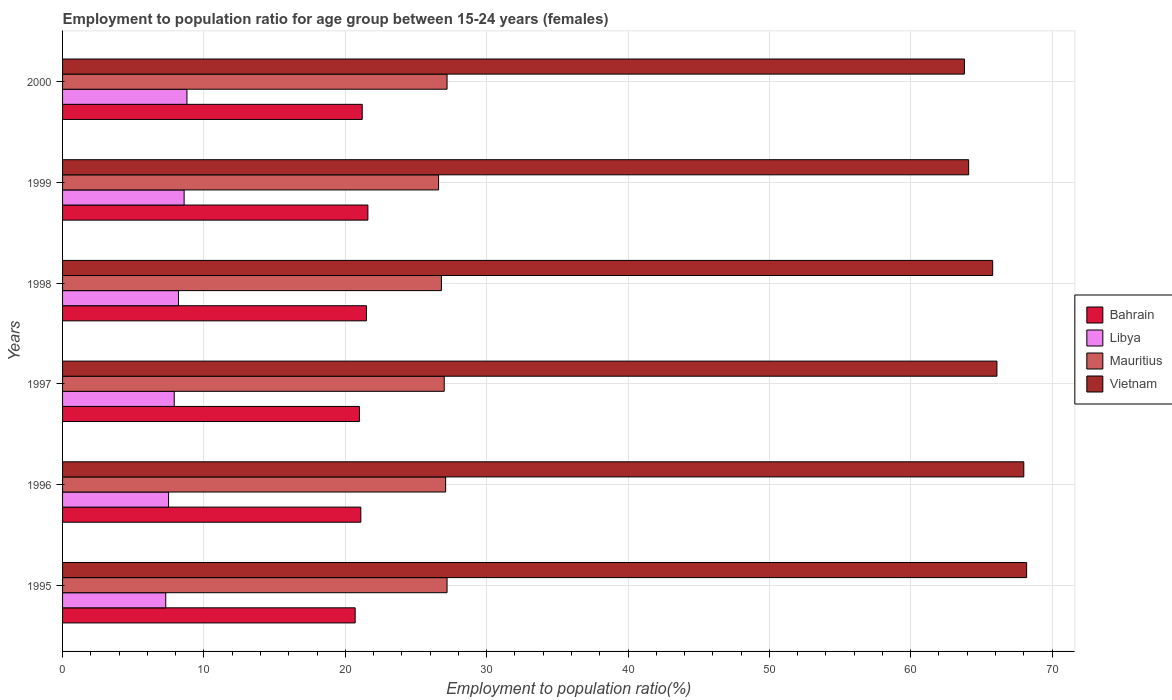How many different coloured bars are there?
Your answer should be very brief. 4. How many bars are there on the 1st tick from the top?
Your answer should be compact. 4. What is the label of the 5th group of bars from the top?
Offer a terse response. 1996. In how many cases, is the number of bars for a given year not equal to the number of legend labels?
Your response must be concise. 0. Across all years, what is the maximum employment to population ratio in Libya?
Provide a short and direct response. 8.8. Across all years, what is the minimum employment to population ratio in Libya?
Offer a terse response. 7.3. In which year was the employment to population ratio in Mauritius maximum?
Offer a very short reply. 1995. In which year was the employment to population ratio in Mauritius minimum?
Offer a very short reply. 1999. What is the total employment to population ratio in Vietnam in the graph?
Your answer should be compact. 396. What is the difference between the employment to population ratio in Vietnam in 1995 and that in 1997?
Your answer should be compact. 2.1. What is the difference between the employment to population ratio in Vietnam in 2000 and the employment to population ratio in Mauritius in 1999?
Your answer should be very brief. 37.2. What is the average employment to population ratio in Mauritius per year?
Give a very brief answer. 26.98. In the year 1998, what is the difference between the employment to population ratio in Libya and employment to population ratio in Bahrain?
Your answer should be compact. -13.3. In how many years, is the employment to population ratio in Mauritius greater than 48 %?
Keep it short and to the point. 0. What is the ratio of the employment to population ratio in Vietnam in 1996 to that in 1998?
Your response must be concise. 1.03. What is the difference between the highest and the second highest employment to population ratio in Libya?
Your answer should be very brief. 0.2. What is the difference between the highest and the lowest employment to population ratio in Mauritius?
Your answer should be very brief. 0.6. Is it the case that in every year, the sum of the employment to population ratio in Mauritius and employment to population ratio in Libya is greater than the sum of employment to population ratio in Bahrain and employment to population ratio in Vietnam?
Offer a terse response. No. What does the 2nd bar from the top in 2000 represents?
Your answer should be compact. Mauritius. What does the 4th bar from the bottom in 1995 represents?
Your response must be concise. Vietnam. How many bars are there?
Offer a very short reply. 24. Are all the bars in the graph horizontal?
Offer a terse response. Yes. Does the graph contain any zero values?
Make the answer very short. No. Does the graph contain grids?
Your response must be concise. Yes. Where does the legend appear in the graph?
Your answer should be very brief. Center right. How many legend labels are there?
Give a very brief answer. 4. How are the legend labels stacked?
Your answer should be compact. Vertical. What is the title of the graph?
Offer a terse response. Employment to population ratio for age group between 15-24 years (females). What is the Employment to population ratio(%) in Bahrain in 1995?
Provide a short and direct response. 20.7. What is the Employment to population ratio(%) of Libya in 1995?
Your answer should be very brief. 7.3. What is the Employment to population ratio(%) of Mauritius in 1995?
Keep it short and to the point. 27.2. What is the Employment to population ratio(%) of Vietnam in 1995?
Offer a very short reply. 68.2. What is the Employment to population ratio(%) in Bahrain in 1996?
Provide a short and direct response. 21.1. What is the Employment to population ratio(%) of Libya in 1996?
Keep it short and to the point. 7.5. What is the Employment to population ratio(%) of Mauritius in 1996?
Make the answer very short. 27.1. What is the Employment to population ratio(%) of Vietnam in 1996?
Your answer should be very brief. 68. What is the Employment to population ratio(%) in Bahrain in 1997?
Ensure brevity in your answer.  21. What is the Employment to population ratio(%) in Libya in 1997?
Your response must be concise. 7.9. What is the Employment to population ratio(%) of Vietnam in 1997?
Your response must be concise. 66.1. What is the Employment to population ratio(%) in Bahrain in 1998?
Make the answer very short. 21.5. What is the Employment to population ratio(%) of Libya in 1998?
Provide a short and direct response. 8.2. What is the Employment to population ratio(%) in Mauritius in 1998?
Keep it short and to the point. 26.8. What is the Employment to population ratio(%) of Vietnam in 1998?
Your answer should be compact. 65.8. What is the Employment to population ratio(%) in Bahrain in 1999?
Ensure brevity in your answer.  21.6. What is the Employment to population ratio(%) in Libya in 1999?
Keep it short and to the point. 8.6. What is the Employment to population ratio(%) of Mauritius in 1999?
Offer a terse response. 26.6. What is the Employment to population ratio(%) of Vietnam in 1999?
Offer a very short reply. 64.1. What is the Employment to population ratio(%) in Bahrain in 2000?
Keep it short and to the point. 21.2. What is the Employment to population ratio(%) in Libya in 2000?
Your response must be concise. 8.8. What is the Employment to population ratio(%) of Mauritius in 2000?
Make the answer very short. 27.2. What is the Employment to population ratio(%) in Vietnam in 2000?
Provide a short and direct response. 63.8. Across all years, what is the maximum Employment to population ratio(%) of Bahrain?
Your answer should be very brief. 21.6. Across all years, what is the maximum Employment to population ratio(%) in Libya?
Your answer should be very brief. 8.8. Across all years, what is the maximum Employment to population ratio(%) in Mauritius?
Provide a short and direct response. 27.2. Across all years, what is the maximum Employment to population ratio(%) in Vietnam?
Give a very brief answer. 68.2. Across all years, what is the minimum Employment to population ratio(%) in Bahrain?
Ensure brevity in your answer.  20.7. Across all years, what is the minimum Employment to population ratio(%) of Libya?
Offer a terse response. 7.3. Across all years, what is the minimum Employment to population ratio(%) in Mauritius?
Ensure brevity in your answer.  26.6. Across all years, what is the minimum Employment to population ratio(%) in Vietnam?
Give a very brief answer. 63.8. What is the total Employment to population ratio(%) in Bahrain in the graph?
Provide a short and direct response. 127.1. What is the total Employment to population ratio(%) of Libya in the graph?
Your answer should be very brief. 48.3. What is the total Employment to population ratio(%) in Mauritius in the graph?
Make the answer very short. 161.9. What is the total Employment to population ratio(%) in Vietnam in the graph?
Give a very brief answer. 396. What is the difference between the Employment to population ratio(%) of Mauritius in 1995 and that in 1996?
Your response must be concise. 0.1. What is the difference between the Employment to population ratio(%) of Vietnam in 1995 and that in 1996?
Offer a terse response. 0.2. What is the difference between the Employment to population ratio(%) of Bahrain in 1995 and that in 1997?
Offer a terse response. -0.3. What is the difference between the Employment to population ratio(%) in Mauritius in 1995 and that in 1997?
Ensure brevity in your answer.  0.2. What is the difference between the Employment to population ratio(%) of Vietnam in 1995 and that in 1998?
Offer a very short reply. 2.4. What is the difference between the Employment to population ratio(%) in Libya in 1995 and that in 1999?
Your answer should be compact. -1.3. What is the difference between the Employment to population ratio(%) of Mauritius in 1995 and that in 1999?
Your answer should be very brief. 0.6. What is the difference between the Employment to population ratio(%) in Vietnam in 1995 and that in 1999?
Your answer should be compact. 4.1. What is the difference between the Employment to population ratio(%) in Libya in 1995 and that in 2000?
Offer a terse response. -1.5. What is the difference between the Employment to population ratio(%) of Mauritius in 1995 and that in 2000?
Your response must be concise. 0. What is the difference between the Employment to population ratio(%) in Bahrain in 1996 and that in 1997?
Provide a short and direct response. 0.1. What is the difference between the Employment to population ratio(%) of Mauritius in 1996 and that in 1997?
Provide a succinct answer. 0.1. What is the difference between the Employment to population ratio(%) of Vietnam in 1996 and that in 1997?
Offer a very short reply. 1.9. What is the difference between the Employment to population ratio(%) of Bahrain in 1996 and that in 1998?
Provide a short and direct response. -0.4. What is the difference between the Employment to population ratio(%) of Vietnam in 1996 and that in 1998?
Make the answer very short. 2.2. What is the difference between the Employment to population ratio(%) of Bahrain in 1996 and that in 2000?
Provide a short and direct response. -0.1. What is the difference between the Employment to population ratio(%) of Libya in 1996 and that in 2000?
Your answer should be very brief. -1.3. What is the difference between the Employment to population ratio(%) in Mauritius in 1996 and that in 2000?
Your answer should be compact. -0.1. What is the difference between the Employment to population ratio(%) of Libya in 1997 and that in 1998?
Your response must be concise. -0.3. What is the difference between the Employment to population ratio(%) of Mauritius in 1997 and that in 1998?
Give a very brief answer. 0.2. What is the difference between the Employment to population ratio(%) in Vietnam in 1997 and that in 1998?
Keep it short and to the point. 0.3. What is the difference between the Employment to population ratio(%) in Vietnam in 1997 and that in 1999?
Your answer should be compact. 2. What is the difference between the Employment to population ratio(%) in Libya in 1997 and that in 2000?
Offer a very short reply. -0.9. What is the difference between the Employment to population ratio(%) in Bahrain in 1998 and that in 1999?
Make the answer very short. -0.1. What is the difference between the Employment to population ratio(%) in Vietnam in 1998 and that in 1999?
Ensure brevity in your answer.  1.7. What is the difference between the Employment to population ratio(%) in Mauritius in 1998 and that in 2000?
Your answer should be very brief. -0.4. What is the difference between the Employment to population ratio(%) of Libya in 1999 and that in 2000?
Provide a succinct answer. -0.2. What is the difference between the Employment to population ratio(%) of Mauritius in 1999 and that in 2000?
Your response must be concise. -0.6. What is the difference between the Employment to population ratio(%) in Vietnam in 1999 and that in 2000?
Keep it short and to the point. 0.3. What is the difference between the Employment to population ratio(%) of Bahrain in 1995 and the Employment to population ratio(%) of Mauritius in 1996?
Provide a succinct answer. -6.4. What is the difference between the Employment to population ratio(%) of Bahrain in 1995 and the Employment to population ratio(%) of Vietnam in 1996?
Give a very brief answer. -47.3. What is the difference between the Employment to population ratio(%) of Libya in 1995 and the Employment to population ratio(%) of Mauritius in 1996?
Your response must be concise. -19.8. What is the difference between the Employment to population ratio(%) in Libya in 1995 and the Employment to population ratio(%) in Vietnam in 1996?
Provide a short and direct response. -60.7. What is the difference between the Employment to population ratio(%) of Mauritius in 1995 and the Employment to population ratio(%) of Vietnam in 1996?
Provide a succinct answer. -40.8. What is the difference between the Employment to population ratio(%) of Bahrain in 1995 and the Employment to population ratio(%) of Libya in 1997?
Provide a succinct answer. 12.8. What is the difference between the Employment to population ratio(%) in Bahrain in 1995 and the Employment to population ratio(%) in Vietnam in 1997?
Your response must be concise. -45.4. What is the difference between the Employment to population ratio(%) in Libya in 1995 and the Employment to population ratio(%) in Mauritius in 1997?
Your answer should be very brief. -19.7. What is the difference between the Employment to population ratio(%) in Libya in 1995 and the Employment to population ratio(%) in Vietnam in 1997?
Ensure brevity in your answer.  -58.8. What is the difference between the Employment to population ratio(%) of Mauritius in 1995 and the Employment to population ratio(%) of Vietnam in 1997?
Your answer should be very brief. -38.9. What is the difference between the Employment to population ratio(%) of Bahrain in 1995 and the Employment to population ratio(%) of Libya in 1998?
Keep it short and to the point. 12.5. What is the difference between the Employment to population ratio(%) in Bahrain in 1995 and the Employment to population ratio(%) in Vietnam in 1998?
Make the answer very short. -45.1. What is the difference between the Employment to population ratio(%) in Libya in 1995 and the Employment to population ratio(%) in Mauritius in 1998?
Offer a very short reply. -19.5. What is the difference between the Employment to population ratio(%) of Libya in 1995 and the Employment to population ratio(%) of Vietnam in 1998?
Your answer should be very brief. -58.5. What is the difference between the Employment to population ratio(%) of Mauritius in 1995 and the Employment to population ratio(%) of Vietnam in 1998?
Provide a succinct answer. -38.6. What is the difference between the Employment to population ratio(%) in Bahrain in 1995 and the Employment to population ratio(%) in Libya in 1999?
Your response must be concise. 12.1. What is the difference between the Employment to population ratio(%) of Bahrain in 1995 and the Employment to population ratio(%) of Mauritius in 1999?
Keep it short and to the point. -5.9. What is the difference between the Employment to population ratio(%) of Bahrain in 1995 and the Employment to population ratio(%) of Vietnam in 1999?
Your answer should be very brief. -43.4. What is the difference between the Employment to population ratio(%) in Libya in 1995 and the Employment to population ratio(%) in Mauritius in 1999?
Provide a succinct answer. -19.3. What is the difference between the Employment to population ratio(%) of Libya in 1995 and the Employment to population ratio(%) of Vietnam in 1999?
Provide a short and direct response. -56.8. What is the difference between the Employment to population ratio(%) of Mauritius in 1995 and the Employment to population ratio(%) of Vietnam in 1999?
Make the answer very short. -36.9. What is the difference between the Employment to population ratio(%) of Bahrain in 1995 and the Employment to population ratio(%) of Mauritius in 2000?
Give a very brief answer. -6.5. What is the difference between the Employment to population ratio(%) of Bahrain in 1995 and the Employment to population ratio(%) of Vietnam in 2000?
Make the answer very short. -43.1. What is the difference between the Employment to population ratio(%) in Libya in 1995 and the Employment to population ratio(%) in Mauritius in 2000?
Keep it short and to the point. -19.9. What is the difference between the Employment to population ratio(%) of Libya in 1995 and the Employment to population ratio(%) of Vietnam in 2000?
Give a very brief answer. -56.5. What is the difference between the Employment to population ratio(%) in Mauritius in 1995 and the Employment to population ratio(%) in Vietnam in 2000?
Provide a short and direct response. -36.6. What is the difference between the Employment to population ratio(%) of Bahrain in 1996 and the Employment to population ratio(%) of Libya in 1997?
Your answer should be very brief. 13.2. What is the difference between the Employment to population ratio(%) of Bahrain in 1996 and the Employment to population ratio(%) of Mauritius in 1997?
Offer a very short reply. -5.9. What is the difference between the Employment to population ratio(%) of Bahrain in 1996 and the Employment to population ratio(%) of Vietnam in 1997?
Make the answer very short. -45. What is the difference between the Employment to population ratio(%) of Libya in 1996 and the Employment to population ratio(%) of Mauritius in 1997?
Keep it short and to the point. -19.5. What is the difference between the Employment to population ratio(%) in Libya in 1996 and the Employment to population ratio(%) in Vietnam in 1997?
Your answer should be compact. -58.6. What is the difference between the Employment to population ratio(%) of Mauritius in 1996 and the Employment to population ratio(%) of Vietnam in 1997?
Keep it short and to the point. -39. What is the difference between the Employment to population ratio(%) of Bahrain in 1996 and the Employment to population ratio(%) of Libya in 1998?
Your answer should be very brief. 12.9. What is the difference between the Employment to population ratio(%) of Bahrain in 1996 and the Employment to population ratio(%) of Mauritius in 1998?
Your response must be concise. -5.7. What is the difference between the Employment to population ratio(%) of Bahrain in 1996 and the Employment to population ratio(%) of Vietnam in 1998?
Your answer should be very brief. -44.7. What is the difference between the Employment to population ratio(%) in Libya in 1996 and the Employment to population ratio(%) in Mauritius in 1998?
Your answer should be very brief. -19.3. What is the difference between the Employment to population ratio(%) in Libya in 1996 and the Employment to population ratio(%) in Vietnam in 1998?
Your answer should be very brief. -58.3. What is the difference between the Employment to population ratio(%) of Mauritius in 1996 and the Employment to population ratio(%) of Vietnam in 1998?
Make the answer very short. -38.7. What is the difference between the Employment to population ratio(%) in Bahrain in 1996 and the Employment to population ratio(%) in Mauritius in 1999?
Offer a terse response. -5.5. What is the difference between the Employment to population ratio(%) of Bahrain in 1996 and the Employment to population ratio(%) of Vietnam in 1999?
Your response must be concise. -43. What is the difference between the Employment to population ratio(%) of Libya in 1996 and the Employment to population ratio(%) of Mauritius in 1999?
Your response must be concise. -19.1. What is the difference between the Employment to population ratio(%) in Libya in 1996 and the Employment to population ratio(%) in Vietnam in 1999?
Ensure brevity in your answer.  -56.6. What is the difference between the Employment to population ratio(%) in Mauritius in 1996 and the Employment to population ratio(%) in Vietnam in 1999?
Offer a very short reply. -37. What is the difference between the Employment to population ratio(%) of Bahrain in 1996 and the Employment to population ratio(%) of Vietnam in 2000?
Provide a succinct answer. -42.7. What is the difference between the Employment to population ratio(%) in Libya in 1996 and the Employment to population ratio(%) in Mauritius in 2000?
Give a very brief answer. -19.7. What is the difference between the Employment to population ratio(%) in Libya in 1996 and the Employment to population ratio(%) in Vietnam in 2000?
Provide a succinct answer. -56.3. What is the difference between the Employment to population ratio(%) in Mauritius in 1996 and the Employment to population ratio(%) in Vietnam in 2000?
Give a very brief answer. -36.7. What is the difference between the Employment to population ratio(%) of Bahrain in 1997 and the Employment to population ratio(%) of Mauritius in 1998?
Provide a succinct answer. -5.8. What is the difference between the Employment to population ratio(%) of Bahrain in 1997 and the Employment to population ratio(%) of Vietnam in 1998?
Your answer should be very brief. -44.8. What is the difference between the Employment to population ratio(%) in Libya in 1997 and the Employment to population ratio(%) in Mauritius in 1998?
Your answer should be compact. -18.9. What is the difference between the Employment to population ratio(%) of Libya in 1997 and the Employment to population ratio(%) of Vietnam in 1998?
Keep it short and to the point. -57.9. What is the difference between the Employment to population ratio(%) of Mauritius in 1997 and the Employment to population ratio(%) of Vietnam in 1998?
Offer a very short reply. -38.8. What is the difference between the Employment to population ratio(%) in Bahrain in 1997 and the Employment to population ratio(%) in Libya in 1999?
Provide a succinct answer. 12.4. What is the difference between the Employment to population ratio(%) of Bahrain in 1997 and the Employment to population ratio(%) of Vietnam in 1999?
Your answer should be very brief. -43.1. What is the difference between the Employment to population ratio(%) in Libya in 1997 and the Employment to population ratio(%) in Mauritius in 1999?
Give a very brief answer. -18.7. What is the difference between the Employment to population ratio(%) in Libya in 1997 and the Employment to population ratio(%) in Vietnam in 1999?
Keep it short and to the point. -56.2. What is the difference between the Employment to population ratio(%) of Mauritius in 1997 and the Employment to population ratio(%) of Vietnam in 1999?
Keep it short and to the point. -37.1. What is the difference between the Employment to population ratio(%) in Bahrain in 1997 and the Employment to population ratio(%) in Libya in 2000?
Ensure brevity in your answer.  12.2. What is the difference between the Employment to population ratio(%) of Bahrain in 1997 and the Employment to population ratio(%) of Vietnam in 2000?
Make the answer very short. -42.8. What is the difference between the Employment to population ratio(%) in Libya in 1997 and the Employment to population ratio(%) in Mauritius in 2000?
Keep it short and to the point. -19.3. What is the difference between the Employment to population ratio(%) in Libya in 1997 and the Employment to population ratio(%) in Vietnam in 2000?
Your answer should be very brief. -55.9. What is the difference between the Employment to population ratio(%) of Mauritius in 1997 and the Employment to population ratio(%) of Vietnam in 2000?
Your answer should be very brief. -36.8. What is the difference between the Employment to population ratio(%) of Bahrain in 1998 and the Employment to population ratio(%) of Libya in 1999?
Give a very brief answer. 12.9. What is the difference between the Employment to population ratio(%) of Bahrain in 1998 and the Employment to population ratio(%) of Mauritius in 1999?
Give a very brief answer. -5.1. What is the difference between the Employment to population ratio(%) in Bahrain in 1998 and the Employment to population ratio(%) in Vietnam in 1999?
Provide a succinct answer. -42.6. What is the difference between the Employment to population ratio(%) in Libya in 1998 and the Employment to population ratio(%) in Mauritius in 1999?
Provide a short and direct response. -18.4. What is the difference between the Employment to population ratio(%) of Libya in 1998 and the Employment to population ratio(%) of Vietnam in 1999?
Give a very brief answer. -55.9. What is the difference between the Employment to population ratio(%) of Mauritius in 1998 and the Employment to population ratio(%) of Vietnam in 1999?
Keep it short and to the point. -37.3. What is the difference between the Employment to population ratio(%) of Bahrain in 1998 and the Employment to population ratio(%) of Libya in 2000?
Your answer should be very brief. 12.7. What is the difference between the Employment to population ratio(%) of Bahrain in 1998 and the Employment to population ratio(%) of Mauritius in 2000?
Your answer should be very brief. -5.7. What is the difference between the Employment to population ratio(%) in Bahrain in 1998 and the Employment to population ratio(%) in Vietnam in 2000?
Keep it short and to the point. -42.3. What is the difference between the Employment to population ratio(%) in Libya in 1998 and the Employment to population ratio(%) in Mauritius in 2000?
Give a very brief answer. -19. What is the difference between the Employment to population ratio(%) of Libya in 1998 and the Employment to population ratio(%) of Vietnam in 2000?
Your answer should be very brief. -55.6. What is the difference between the Employment to population ratio(%) in Mauritius in 1998 and the Employment to population ratio(%) in Vietnam in 2000?
Give a very brief answer. -37. What is the difference between the Employment to population ratio(%) of Bahrain in 1999 and the Employment to population ratio(%) of Libya in 2000?
Provide a short and direct response. 12.8. What is the difference between the Employment to population ratio(%) of Bahrain in 1999 and the Employment to population ratio(%) of Vietnam in 2000?
Your response must be concise. -42.2. What is the difference between the Employment to population ratio(%) of Libya in 1999 and the Employment to population ratio(%) of Mauritius in 2000?
Make the answer very short. -18.6. What is the difference between the Employment to population ratio(%) in Libya in 1999 and the Employment to population ratio(%) in Vietnam in 2000?
Offer a terse response. -55.2. What is the difference between the Employment to population ratio(%) of Mauritius in 1999 and the Employment to population ratio(%) of Vietnam in 2000?
Offer a terse response. -37.2. What is the average Employment to population ratio(%) of Bahrain per year?
Your answer should be very brief. 21.18. What is the average Employment to population ratio(%) of Libya per year?
Offer a terse response. 8.05. What is the average Employment to population ratio(%) in Mauritius per year?
Offer a terse response. 26.98. In the year 1995, what is the difference between the Employment to population ratio(%) in Bahrain and Employment to population ratio(%) in Libya?
Provide a short and direct response. 13.4. In the year 1995, what is the difference between the Employment to population ratio(%) in Bahrain and Employment to population ratio(%) in Vietnam?
Your answer should be compact. -47.5. In the year 1995, what is the difference between the Employment to population ratio(%) in Libya and Employment to population ratio(%) in Mauritius?
Make the answer very short. -19.9. In the year 1995, what is the difference between the Employment to population ratio(%) of Libya and Employment to population ratio(%) of Vietnam?
Offer a very short reply. -60.9. In the year 1995, what is the difference between the Employment to population ratio(%) in Mauritius and Employment to population ratio(%) in Vietnam?
Provide a short and direct response. -41. In the year 1996, what is the difference between the Employment to population ratio(%) in Bahrain and Employment to population ratio(%) in Libya?
Give a very brief answer. 13.6. In the year 1996, what is the difference between the Employment to population ratio(%) of Bahrain and Employment to population ratio(%) of Vietnam?
Your response must be concise. -46.9. In the year 1996, what is the difference between the Employment to population ratio(%) of Libya and Employment to population ratio(%) of Mauritius?
Provide a short and direct response. -19.6. In the year 1996, what is the difference between the Employment to population ratio(%) of Libya and Employment to population ratio(%) of Vietnam?
Make the answer very short. -60.5. In the year 1996, what is the difference between the Employment to population ratio(%) in Mauritius and Employment to population ratio(%) in Vietnam?
Your response must be concise. -40.9. In the year 1997, what is the difference between the Employment to population ratio(%) of Bahrain and Employment to population ratio(%) of Libya?
Offer a very short reply. 13.1. In the year 1997, what is the difference between the Employment to population ratio(%) of Bahrain and Employment to population ratio(%) of Vietnam?
Offer a very short reply. -45.1. In the year 1997, what is the difference between the Employment to population ratio(%) in Libya and Employment to population ratio(%) in Mauritius?
Your response must be concise. -19.1. In the year 1997, what is the difference between the Employment to population ratio(%) of Libya and Employment to population ratio(%) of Vietnam?
Provide a succinct answer. -58.2. In the year 1997, what is the difference between the Employment to population ratio(%) of Mauritius and Employment to population ratio(%) of Vietnam?
Give a very brief answer. -39.1. In the year 1998, what is the difference between the Employment to population ratio(%) of Bahrain and Employment to population ratio(%) of Libya?
Offer a terse response. 13.3. In the year 1998, what is the difference between the Employment to population ratio(%) in Bahrain and Employment to population ratio(%) in Vietnam?
Ensure brevity in your answer.  -44.3. In the year 1998, what is the difference between the Employment to population ratio(%) of Libya and Employment to population ratio(%) of Mauritius?
Your response must be concise. -18.6. In the year 1998, what is the difference between the Employment to population ratio(%) of Libya and Employment to population ratio(%) of Vietnam?
Keep it short and to the point. -57.6. In the year 1998, what is the difference between the Employment to population ratio(%) of Mauritius and Employment to population ratio(%) of Vietnam?
Make the answer very short. -39. In the year 1999, what is the difference between the Employment to population ratio(%) of Bahrain and Employment to population ratio(%) of Vietnam?
Offer a very short reply. -42.5. In the year 1999, what is the difference between the Employment to population ratio(%) in Libya and Employment to population ratio(%) in Mauritius?
Keep it short and to the point. -18. In the year 1999, what is the difference between the Employment to population ratio(%) of Libya and Employment to population ratio(%) of Vietnam?
Offer a terse response. -55.5. In the year 1999, what is the difference between the Employment to population ratio(%) of Mauritius and Employment to population ratio(%) of Vietnam?
Offer a very short reply. -37.5. In the year 2000, what is the difference between the Employment to population ratio(%) of Bahrain and Employment to population ratio(%) of Libya?
Offer a terse response. 12.4. In the year 2000, what is the difference between the Employment to population ratio(%) of Bahrain and Employment to population ratio(%) of Vietnam?
Provide a short and direct response. -42.6. In the year 2000, what is the difference between the Employment to population ratio(%) of Libya and Employment to population ratio(%) of Mauritius?
Give a very brief answer. -18.4. In the year 2000, what is the difference between the Employment to population ratio(%) in Libya and Employment to population ratio(%) in Vietnam?
Make the answer very short. -55. In the year 2000, what is the difference between the Employment to population ratio(%) of Mauritius and Employment to population ratio(%) of Vietnam?
Your answer should be very brief. -36.6. What is the ratio of the Employment to population ratio(%) of Bahrain in 1995 to that in 1996?
Provide a short and direct response. 0.98. What is the ratio of the Employment to population ratio(%) of Libya in 1995 to that in 1996?
Give a very brief answer. 0.97. What is the ratio of the Employment to population ratio(%) of Mauritius in 1995 to that in 1996?
Keep it short and to the point. 1. What is the ratio of the Employment to population ratio(%) of Bahrain in 1995 to that in 1997?
Your answer should be very brief. 0.99. What is the ratio of the Employment to population ratio(%) in Libya in 1995 to that in 1997?
Your answer should be very brief. 0.92. What is the ratio of the Employment to population ratio(%) in Mauritius in 1995 to that in 1997?
Ensure brevity in your answer.  1.01. What is the ratio of the Employment to population ratio(%) of Vietnam in 1995 to that in 1997?
Your answer should be very brief. 1.03. What is the ratio of the Employment to population ratio(%) in Bahrain in 1995 to that in 1998?
Give a very brief answer. 0.96. What is the ratio of the Employment to population ratio(%) in Libya in 1995 to that in 1998?
Provide a succinct answer. 0.89. What is the ratio of the Employment to population ratio(%) of Mauritius in 1995 to that in 1998?
Your answer should be very brief. 1.01. What is the ratio of the Employment to population ratio(%) in Vietnam in 1995 to that in 1998?
Your answer should be very brief. 1.04. What is the ratio of the Employment to population ratio(%) of Bahrain in 1995 to that in 1999?
Ensure brevity in your answer.  0.96. What is the ratio of the Employment to population ratio(%) in Libya in 1995 to that in 1999?
Your answer should be compact. 0.85. What is the ratio of the Employment to population ratio(%) of Mauritius in 1995 to that in 1999?
Provide a short and direct response. 1.02. What is the ratio of the Employment to population ratio(%) in Vietnam in 1995 to that in 1999?
Ensure brevity in your answer.  1.06. What is the ratio of the Employment to population ratio(%) of Bahrain in 1995 to that in 2000?
Make the answer very short. 0.98. What is the ratio of the Employment to population ratio(%) in Libya in 1995 to that in 2000?
Give a very brief answer. 0.83. What is the ratio of the Employment to population ratio(%) of Vietnam in 1995 to that in 2000?
Keep it short and to the point. 1.07. What is the ratio of the Employment to population ratio(%) of Bahrain in 1996 to that in 1997?
Give a very brief answer. 1. What is the ratio of the Employment to population ratio(%) of Libya in 1996 to that in 1997?
Keep it short and to the point. 0.95. What is the ratio of the Employment to population ratio(%) in Mauritius in 1996 to that in 1997?
Provide a short and direct response. 1. What is the ratio of the Employment to population ratio(%) in Vietnam in 1996 to that in 1997?
Keep it short and to the point. 1.03. What is the ratio of the Employment to population ratio(%) in Bahrain in 1996 to that in 1998?
Make the answer very short. 0.98. What is the ratio of the Employment to population ratio(%) of Libya in 1996 to that in 1998?
Your answer should be very brief. 0.91. What is the ratio of the Employment to population ratio(%) in Mauritius in 1996 to that in 1998?
Make the answer very short. 1.01. What is the ratio of the Employment to population ratio(%) of Vietnam in 1996 to that in 1998?
Keep it short and to the point. 1.03. What is the ratio of the Employment to population ratio(%) of Bahrain in 1996 to that in 1999?
Your response must be concise. 0.98. What is the ratio of the Employment to population ratio(%) in Libya in 1996 to that in 1999?
Ensure brevity in your answer.  0.87. What is the ratio of the Employment to population ratio(%) in Mauritius in 1996 to that in 1999?
Your response must be concise. 1.02. What is the ratio of the Employment to population ratio(%) of Vietnam in 1996 to that in 1999?
Your response must be concise. 1.06. What is the ratio of the Employment to population ratio(%) in Bahrain in 1996 to that in 2000?
Ensure brevity in your answer.  1. What is the ratio of the Employment to population ratio(%) of Libya in 1996 to that in 2000?
Keep it short and to the point. 0.85. What is the ratio of the Employment to population ratio(%) of Mauritius in 1996 to that in 2000?
Provide a short and direct response. 1. What is the ratio of the Employment to population ratio(%) of Vietnam in 1996 to that in 2000?
Make the answer very short. 1.07. What is the ratio of the Employment to population ratio(%) in Bahrain in 1997 to that in 1998?
Your answer should be compact. 0.98. What is the ratio of the Employment to population ratio(%) of Libya in 1997 to that in 1998?
Provide a short and direct response. 0.96. What is the ratio of the Employment to population ratio(%) of Mauritius in 1997 to that in 1998?
Make the answer very short. 1.01. What is the ratio of the Employment to population ratio(%) in Vietnam in 1997 to that in 1998?
Keep it short and to the point. 1. What is the ratio of the Employment to population ratio(%) in Bahrain in 1997 to that in 1999?
Make the answer very short. 0.97. What is the ratio of the Employment to population ratio(%) of Libya in 1997 to that in 1999?
Keep it short and to the point. 0.92. What is the ratio of the Employment to population ratio(%) in Mauritius in 1997 to that in 1999?
Your answer should be compact. 1.01. What is the ratio of the Employment to population ratio(%) of Vietnam in 1997 to that in 1999?
Give a very brief answer. 1.03. What is the ratio of the Employment to population ratio(%) of Bahrain in 1997 to that in 2000?
Your response must be concise. 0.99. What is the ratio of the Employment to population ratio(%) in Libya in 1997 to that in 2000?
Offer a terse response. 0.9. What is the ratio of the Employment to population ratio(%) of Mauritius in 1997 to that in 2000?
Provide a short and direct response. 0.99. What is the ratio of the Employment to population ratio(%) of Vietnam in 1997 to that in 2000?
Your answer should be compact. 1.04. What is the ratio of the Employment to population ratio(%) of Bahrain in 1998 to that in 1999?
Offer a terse response. 1. What is the ratio of the Employment to population ratio(%) in Libya in 1998 to that in 1999?
Ensure brevity in your answer.  0.95. What is the ratio of the Employment to population ratio(%) in Mauritius in 1998 to that in 1999?
Offer a very short reply. 1.01. What is the ratio of the Employment to population ratio(%) of Vietnam in 1998 to that in 1999?
Keep it short and to the point. 1.03. What is the ratio of the Employment to population ratio(%) in Bahrain in 1998 to that in 2000?
Provide a succinct answer. 1.01. What is the ratio of the Employment to population ratio(%) in Libya in 1998 to that in 2000?
Offer a terse response. 0.93. What is the ratio of the Employment to population ratio(%) of Vietnam in 1998 to that in 2000?
Ensure brevity in your answer.  1.03. What is the ratio of the Employment to population ratio(%) of Bahrain in 1999 to that in 2000?
Make the answer very short. 1.02. What is the ratio of the Employment to population ratio(%) of Libya in 1999 to that in 2000?
Offer a terse response. 0.98. What is the ratio of the Employment to population ratio(%) of Mauritius in 1999 to that in 2000?
Provide a succinct answer. 0.98. What is the difference between the highest and the second highest Employment to population ratio(%) of Mauritius?
Your response must be concise. 0. What is the difference between the highest and the lowest Employment to population ratio(%) of Bahrain?
Provide a short and direct response. 0.9. What is the difference between the highest and the lowest Employment to population ratio(%) in Libya?
Your answer should be compact. 1.5. What is the difference between the highest and the lowest Employment to population ratio(%) in Mauritius?
Offer a terse response. 0.6. What is the difference between the highest and the lowest Employment to population ratio(%) in Vietnam?
Give a very brief answer. 4.4. 